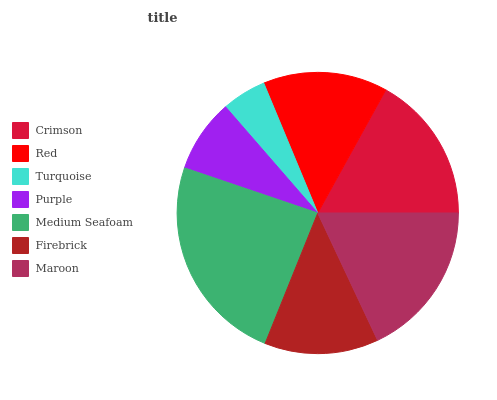Is Turquoise the minimum?
Answer yes or no. Yes. Is Medium Seafoam the maximum?
Answer yes or no. Yes. Is Red the minimum?
Answer yes or no. No. Is Red the maximum?
Answer yes or no. No. Is Crimson greater than Red?
Answer yes or no. Yes. Is Red less than Crimson?
Answer yes or no. Yes. Is Red greater than Crimson?
Answer yes or no. No. Is Crimson less than Red?
Answer yes or no. No. Is Red the high median?
Answer yes or no. Yes. Is Red the low median?
Answer yes or no. Yes. Is Turquoise the high median?
Answer yes or no. No. Is Maroon the low median?
Answer yes or no. No. 